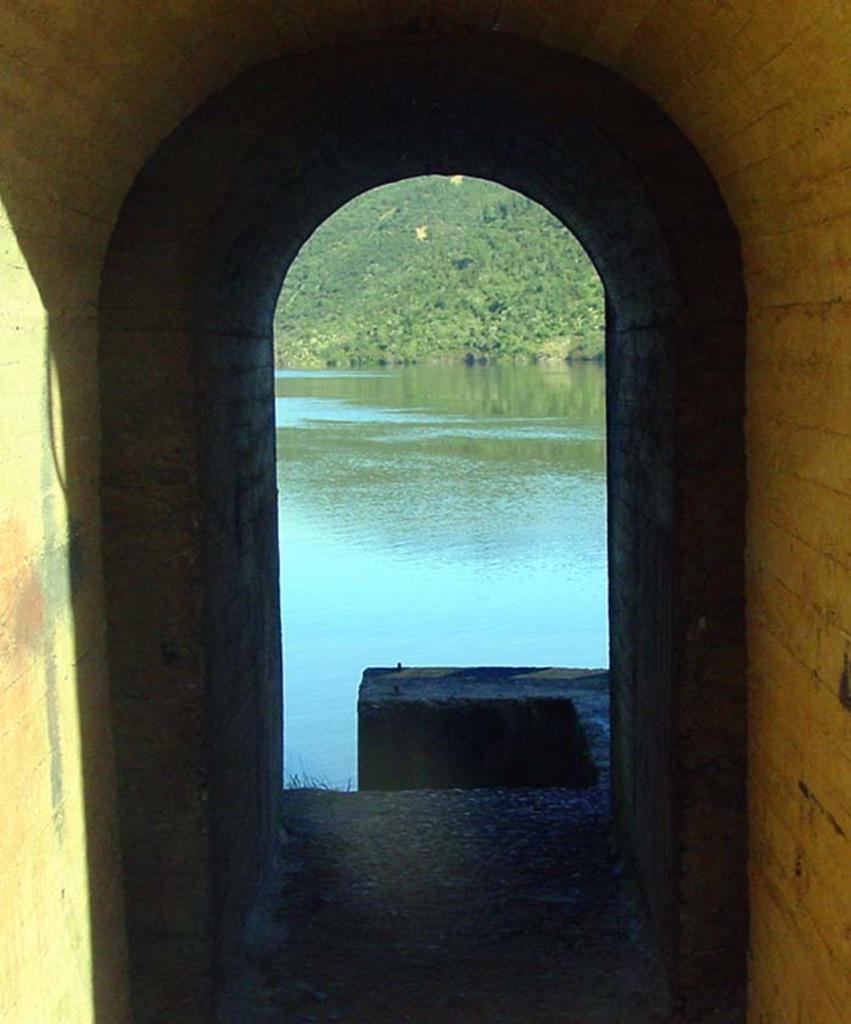Describe this image in one or two sentences. In this image I see the tunnel and I see the path over here. In the background I see the water and I see the greenery over here. 